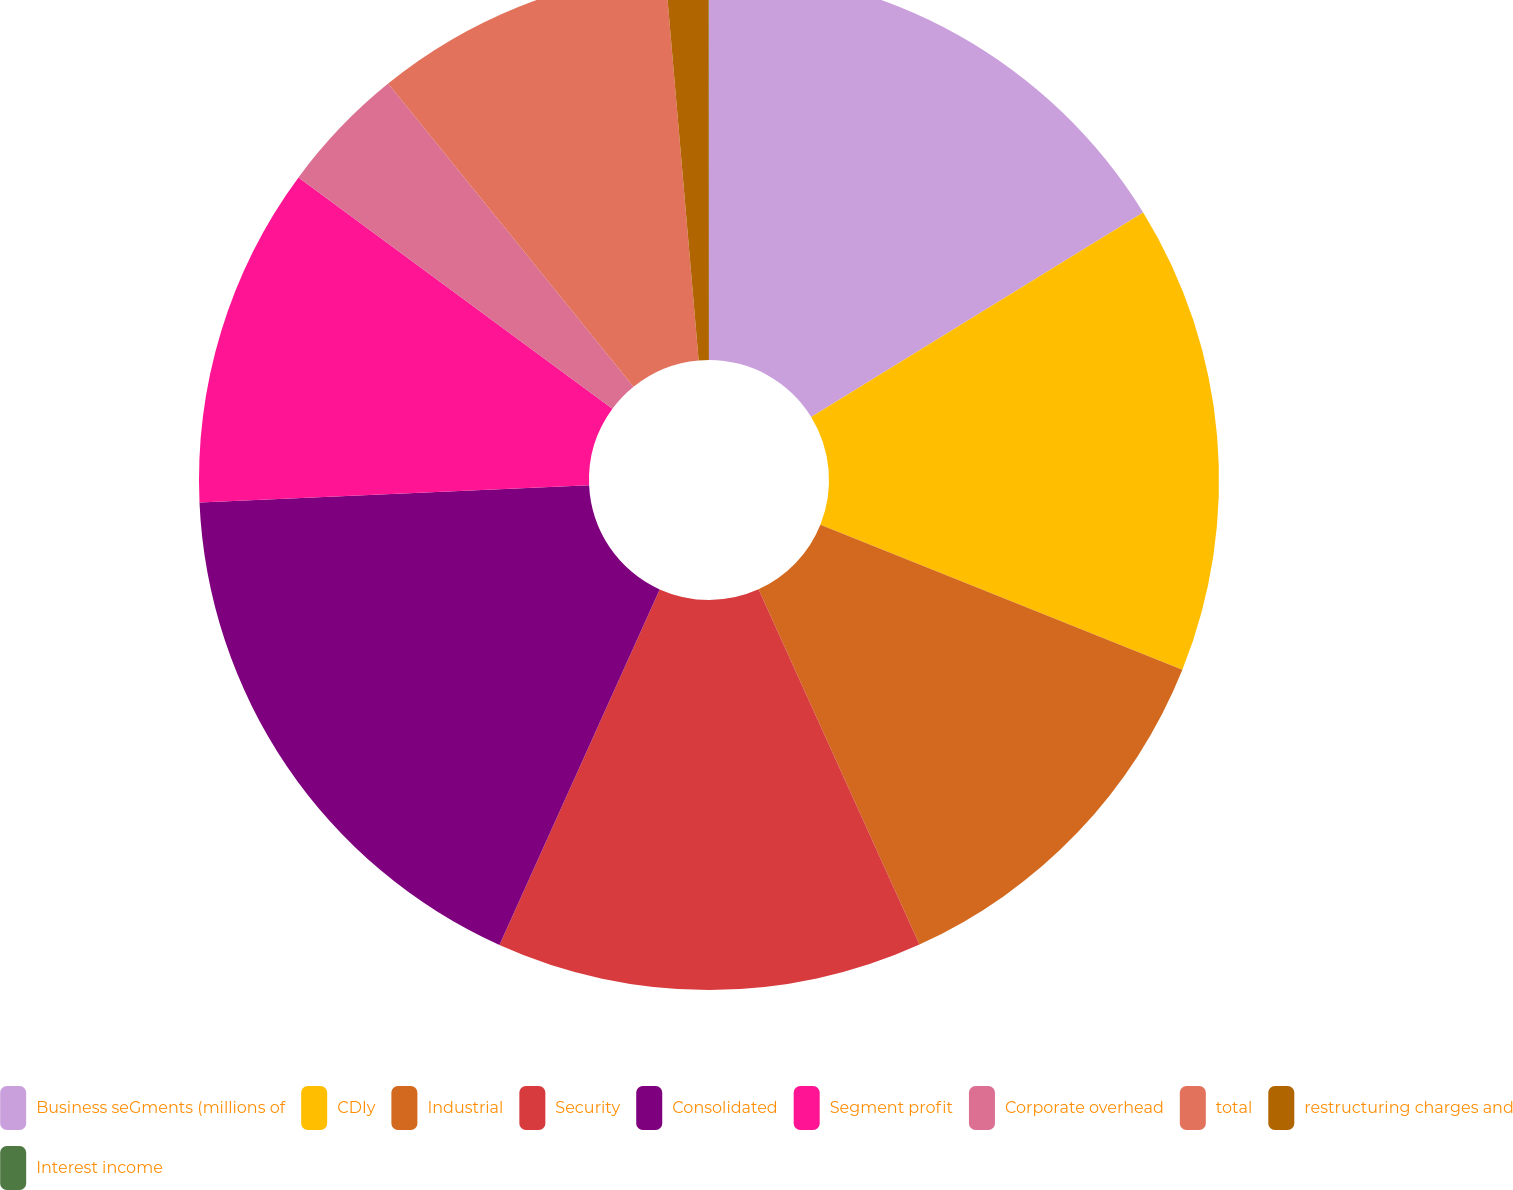Convert chart. <chart><loc_0><loc_0><loc_500><loc_500><pie_chart><fcel>Business seGments (millions of<fcel>CDIy<fcel>Industrial<fcel>Security<fcel>Consolidated<fcel>Segment profit<fcel>Corporate overhead<fcel>total<fcel>restructuring charges and<fcel>Interest income<nl><fcel>16.21%<fcel>14.86%<fcel>12.16%<fcel>13.51%<fcel>17.56%<fcel>10.81%<fcel>4.06%<fcel>9.46%<fcel>1.36%<fcel>0.01%<nl></chart> 